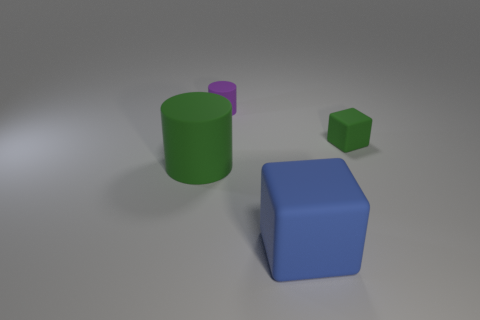Is there a small object that is in front of the green object on the right side of the large block? no 